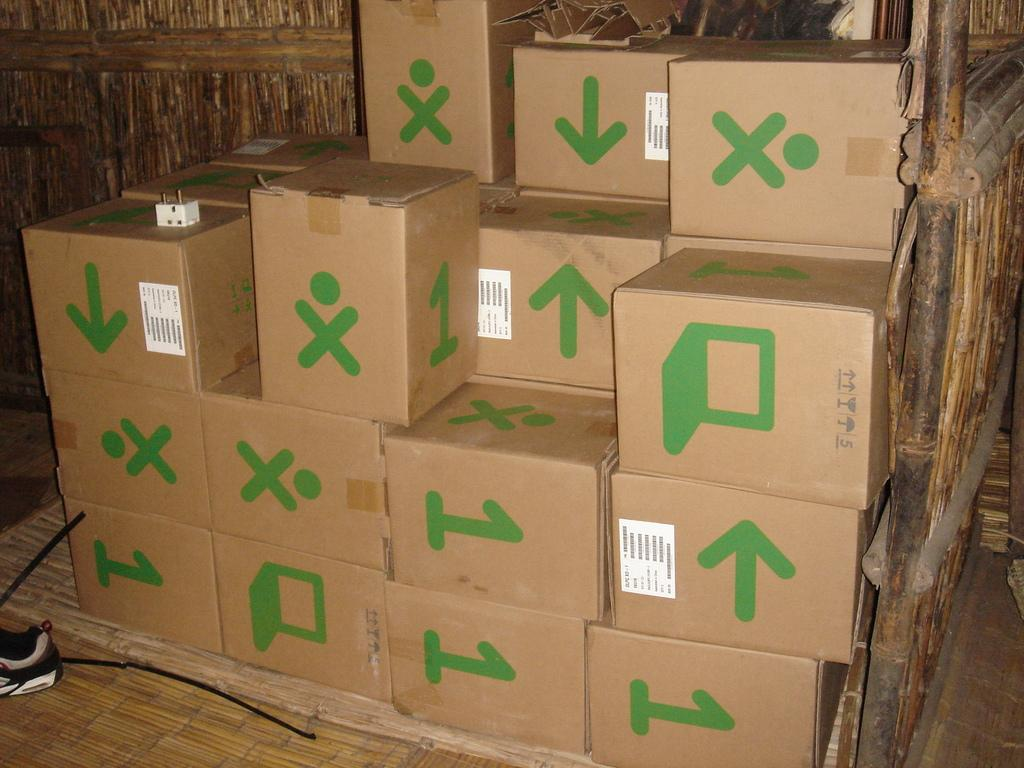Provide a one-sentence caption for the provided image. Cardboard boxes are piled up, some having the number 1 on them and others featuring the letter X. 